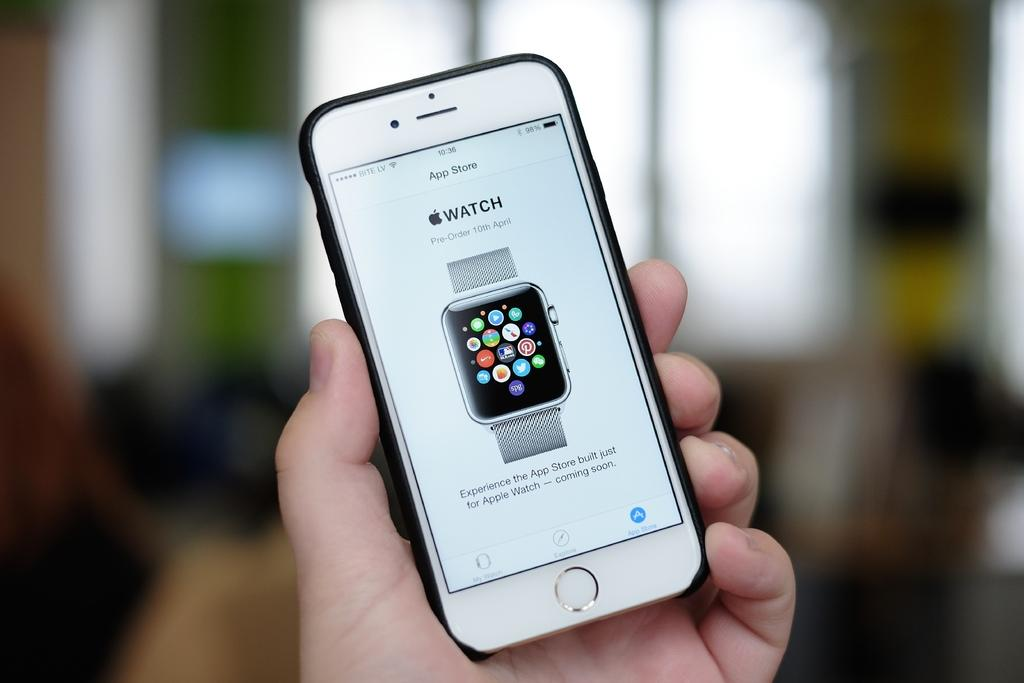<image>
Offer a succinct explanation of the picture presented. An iPhone screen says you can pre-order the apple watch. 